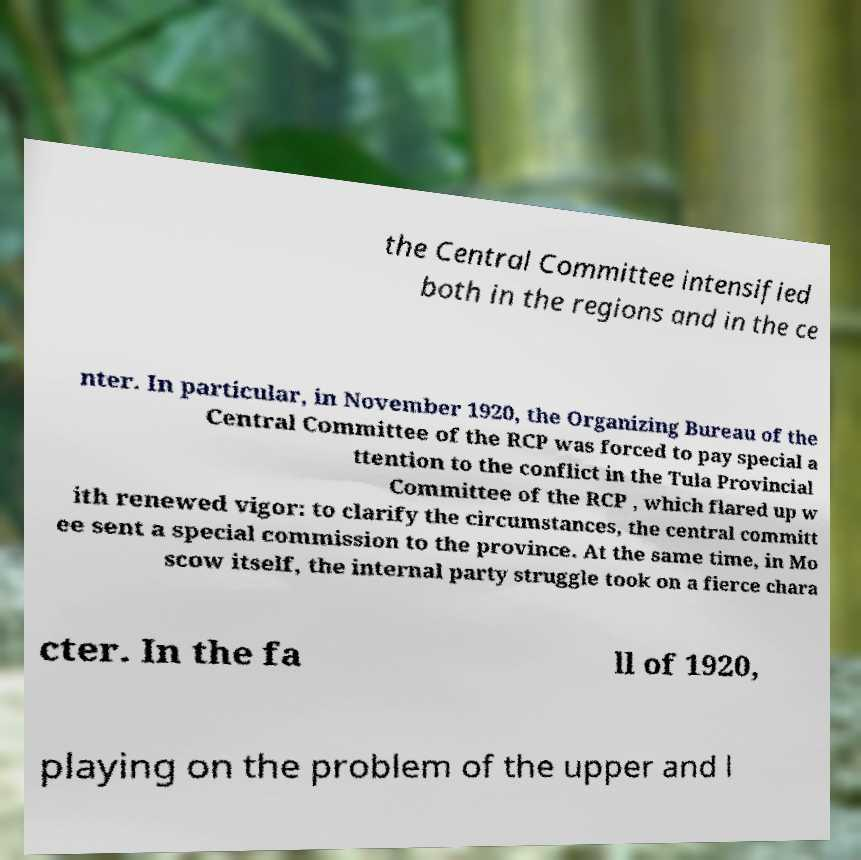Can you accurately transcribe the text from the provided image for me? the Central Committee intensified both in the regions and in the ce nter. In particular, in November 1920, the Organizing Bureau of the Central Committee of the RCP was forced to pay special a ttention to the conflict in the Tula Provincial Committee of the RCP , which flared up w ith renewed vigor: to clarify the circumstances, the central committ ee sent a special commission to the province. At the same time, in Mo scow itself, the internal party struggle took on a fierce chara cter. In the fa ll of 1920, playing on the problem of the upper and l 